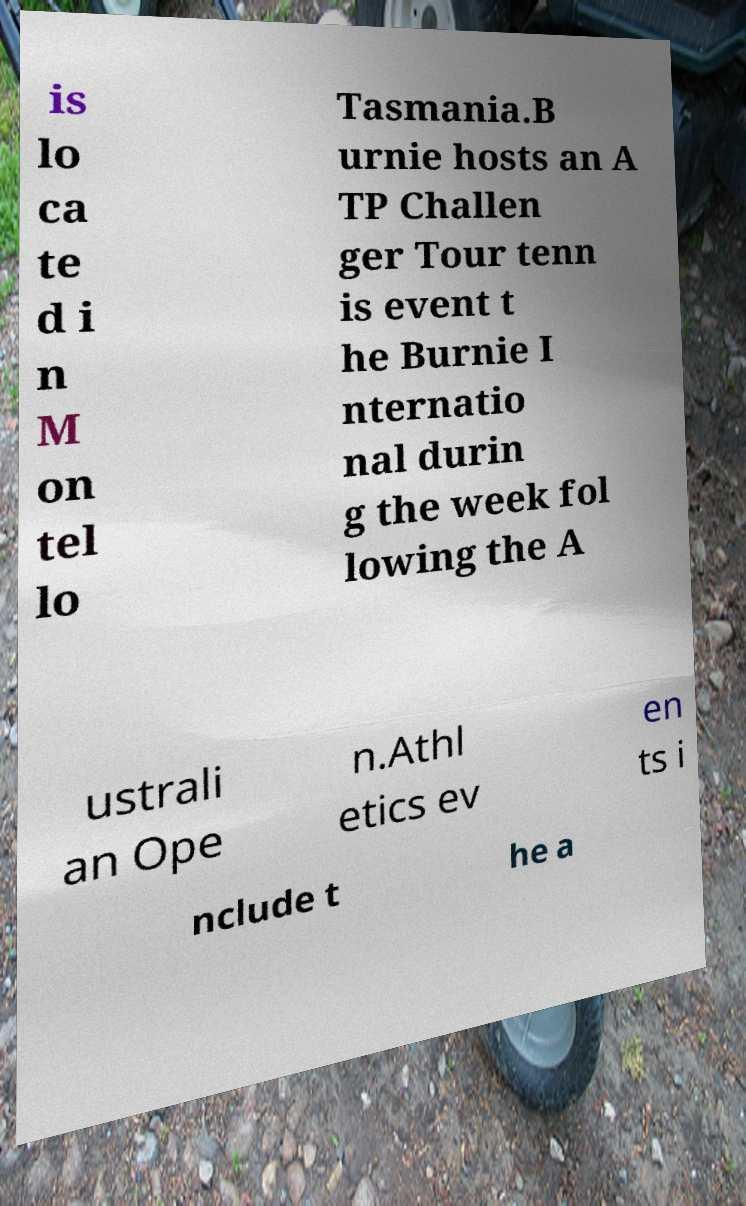Can you accurately transcribe the text from the provided image for me? is lo ca te d i n M on tel lo Tasmania.B urnie hosts an A TP Challen ger Tour tenn is event t he Burnie I nternatio nal durin g the week fol lowing the A ustrali an Ope n.Athl etics ev en ts i nclude t he a 